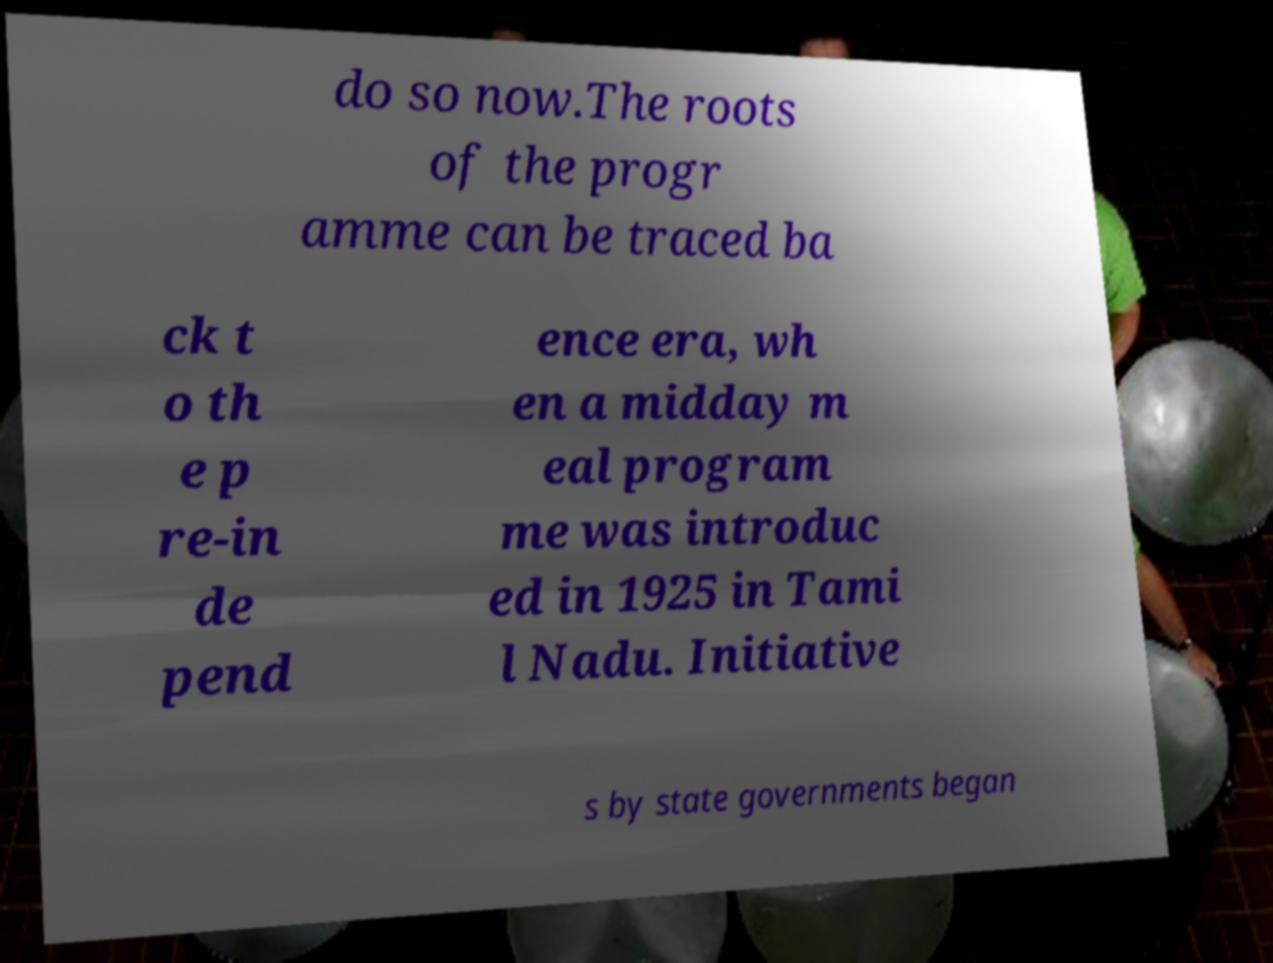Please identify and transcribe the text found in this image. do so now.The roots of the progr amme can be traced ba ck t o th e p re-in de pend ence era, wh en a midday m eal program me was introduc ed in 1925 in Tami l Nadu. Initiative s by state governments began 